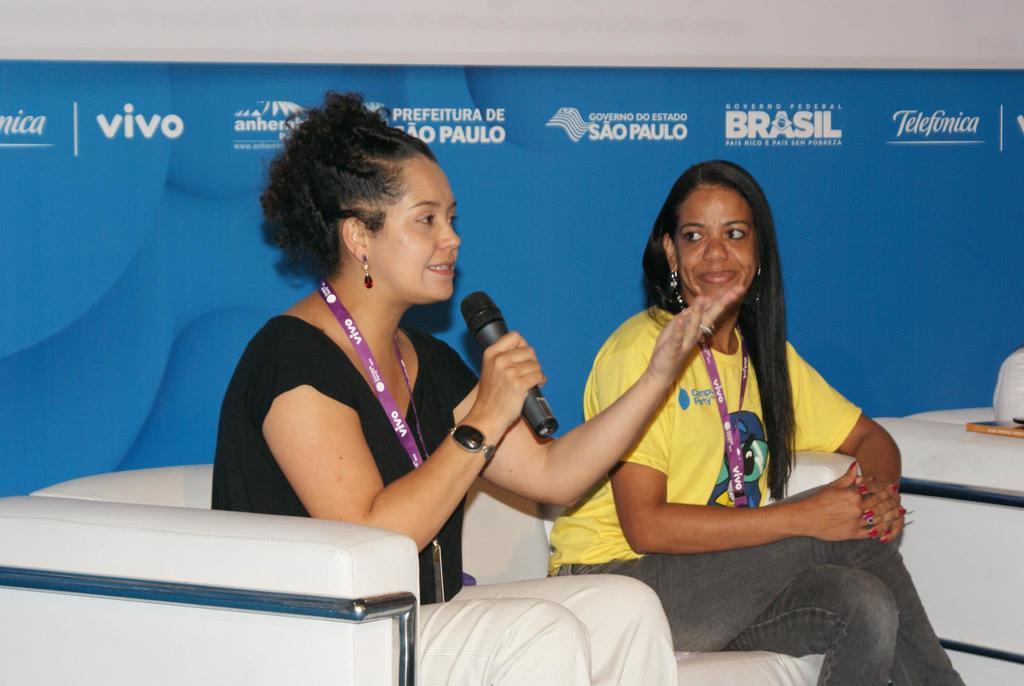Could you give a brief overview of what you see in this image? In the picture I can see two women sitting on the sofa and I can see one of them speaking on a microphone. I can see the tag on their neck. In the background, I can see the hoarding. 